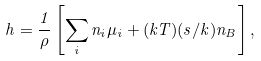Convert formula to latex. <formula><loc_0><loc_0><loc_500><loc_500>h = \frac { 1 } { \rho } \left [ \sum _ { i } n _ { i } \mu _ { i } + ( k T ) ( s / k ) n _ { B } \right ] ,</formula> 